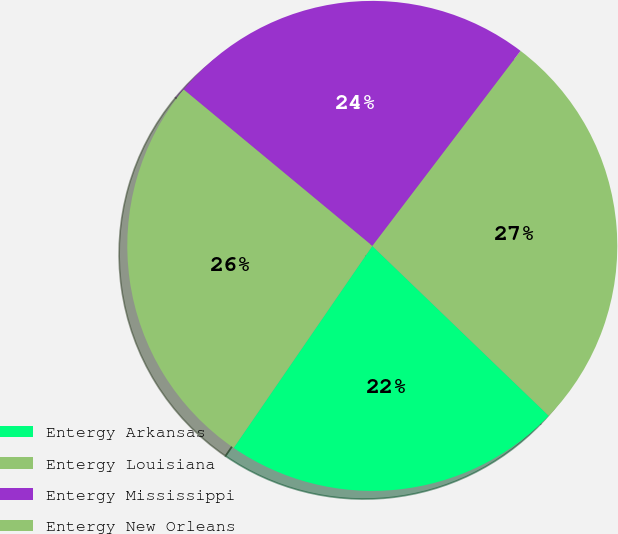Convert chart to OTSL. <chart><loc_0><loc_0><loc_500><loc_500><pie_chart><fcel>Entergy Arkansas<fcel>Entergy Louisiana<fcel>Entergy Mississippi<fcel>Entergy New Orleans<nl><fcel>22.38%<fcel>26.85%<fcel>24.33%<fcel>26.44%<nl></chart> 